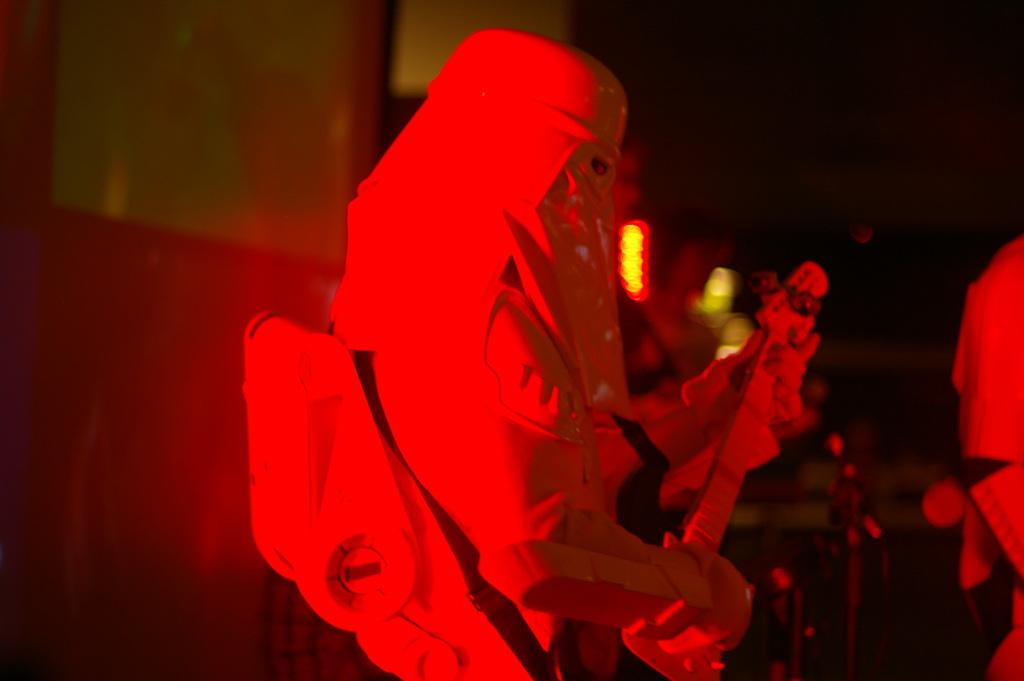Who is the main subject in the image? There is a man in the image. What is the man wearing? The man is wearing a white dress. What is the man doing in the image? The man is playing a guitar. Where is the man located in the image? The man is on a stage. What can be observed about the background of the image? The background of the image is blurred. What type of laborer is the man in the image? The man is not a laborer; he is playing a guitar on a stage. What color is the shirt the man is wearing? The man is not wearing a shirt; he is wearing a white dress. 